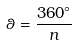Convert formula to latex. <formula><loc_0><loc_0><loc_500><loc_500>\theta = \frac { 3 6 0 ^ { \circ } } { n }</formula> 